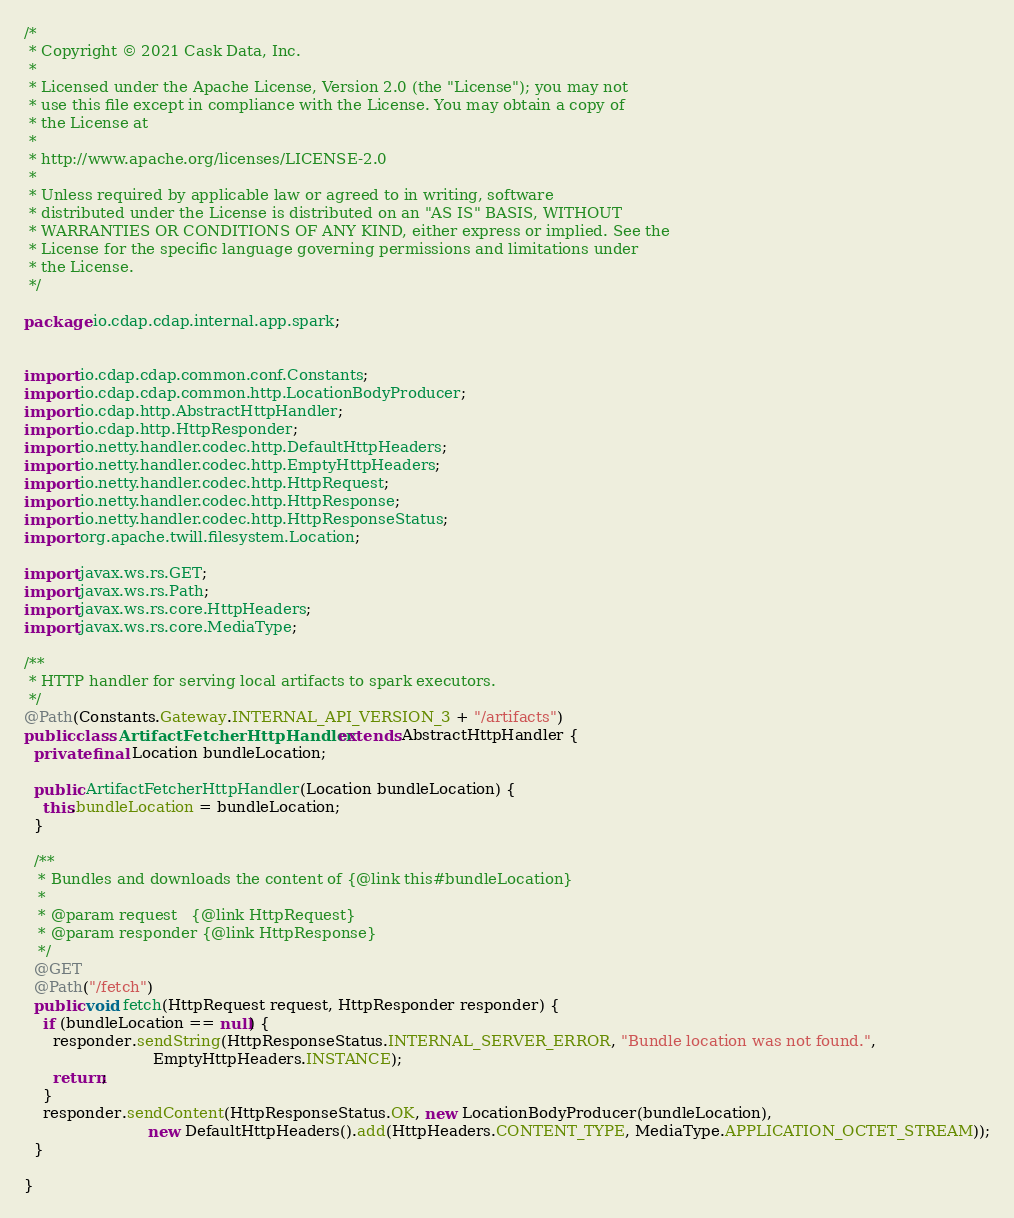<code> <loc_0><loc_0><loc_500><loc_500><_Java_>/*
 * Copyright © 2021 Cask Data, Inc.
 *
 * Licensed under the Apache License, Version 2.0 (the "License"); you may not
 * use this file except in compliance with the License. You may obtain a copy of
 * the License at
 *
 * http://www.apache.org/licenses/LICENSE-2.0
 *
 * Unless required by applicable law or agreed to in writing, software
 * distributed under the License is distributed on an "AS IS" BASIS, WITHOUT
 * WARRANTIES OR CONDITIONS OF ANY KIND, either express or implied. See the
 * License for the specific language governing permissions and limitations under
 * the License.
 */

package io.cdap.cdap.internal.app.spark;


import io.cdap.cdap.common.conf.Constants;
import io.cdap.cdap.common.http.LocationBodyProducer;
import io.cdap.http.AbstractHttpHandler;
import io.cdap.http.HttpResponder;
import io.netty.handler.codec.http.DefaultHttpHeaders;
import io.netty.handler.codec.http.EmptyHttpHeaders;
import io.netty.handler.codec.http.HttpRequest;
import io.netty.handler.codec.http.HttpResponse;
import io.netty.handler.codec.http.HttpResponseStatus;
import org.apache.twill.filesystem.Location;

import javax.ws.rs.GET;
import javax.ws.rs.Path;
import javax.ws.rs.core.HttpHeaders;
import javax.ws.rs.core.MediaType;

/**
 * HTTP handler for serving local artifacts to spark executors.
 */
@Path(Constants.Gateway.INTERNAL_API_VERSION_3 + "/artifacts")
public class ArtifactFetcherHttpHandler extends AbstractHttpHandler {
  private final Location bundleLocation;

  public ArtifactFetcherHttpHandler(Location bundleLocation) {
    this.bundleLocation = bundleLocation;
  }

  /**
   * Bundles and downloads the content of {@link this#bundleLocation}
   *
   * @param request   {@link HttpRequest}
   * @param responder {@link HttpResponse}
   */
  @GET
  @Path("/fetch")
  public void fetch(HttpRequest request, HttpResponder responder) {
    if (bundleLocation == null) {
      responder.sendString(HttpResponseStatus.INTERNAL_SERVER_ERROR, "Bundle location was not found.",
                           EmptyHttpHeaders.INSTANCE);
      return;
    }
    responder.sendContent(HttpResponseStatus.OK, new LocationBodyProducer(bundleLocation),
                          new DefaultHttpHeaders().add(HttpHeaders.CONTENT_TYPE, MediaType.APPLICATION_OCTET_STREAM));
  }

}
</code> 